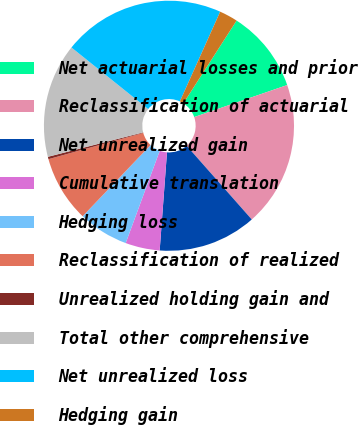<chart> <loc_0><loc_0><loc_500><loc_500><pie_chart><fcel>Net actuarial losses and prior<fcel>Reclassification of actuarial<fcel>Net unrealized gain<fcel>Cumulative translation<fcel>Hedging loss<fcel>Reclassification of realized<fcel>Unrealized holding gain and<fcel>Total other comprehensive<fcel>Net unrealized loss<fcel>Hedging gain<nl><fcel>10.63%<fcel>18.76%<fcel>12.7%<fcel>4.44%<fcel>6.5%<fcel>8.57%<fcel>0.31%<fcel>14.76%<fcel>20.95%<fcel>2.38%<nl></chart> 